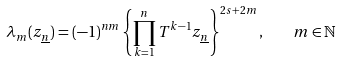<formula> <loc_0><loc_0><loc_500><loc_500>\lambda _ { m } ( z _ { \underline { n } } ) = ( - 1 ) ^ { n m } \left \{ \prod _ { k = 1 } ^ { n } T ^ { k - 1 } z _ { \underline { n } } \right \} ^ { 2 s + 2 m } , \quad m \in \mathbb { N }</formula> 